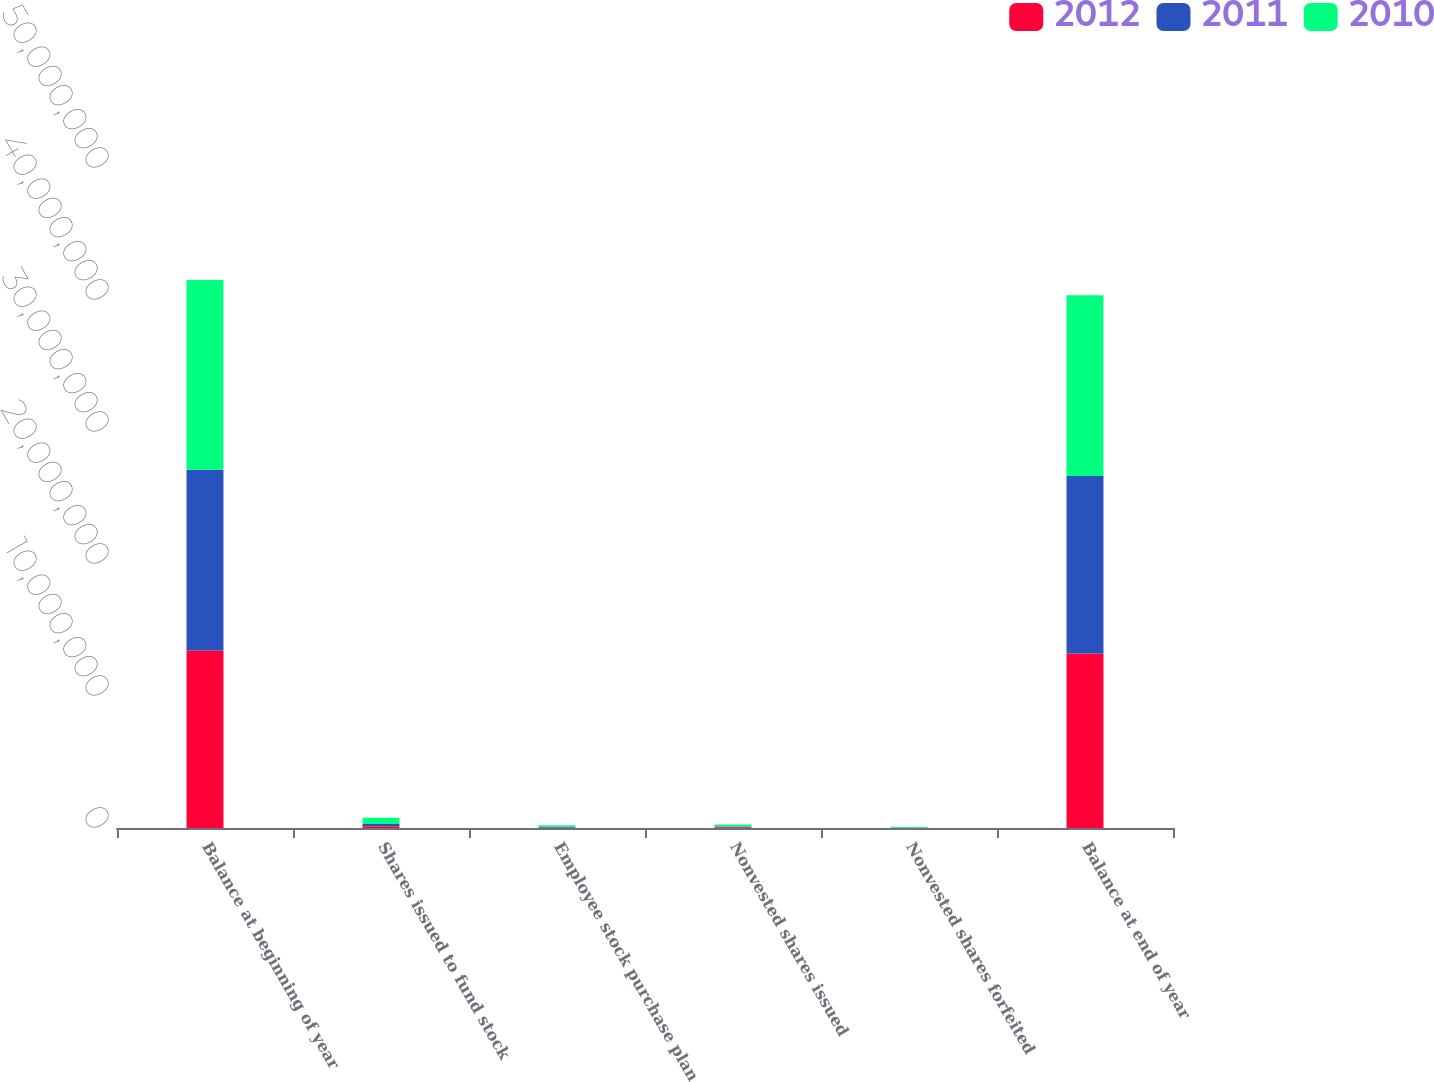Convert chart. <chart><loc_0><loc_0><loc_500><loc_500><stacked_bar_chart><ecel><fcel>Balance at beginning of year<fcel>Shares issued to fund stock<fcel>Employee stock purchase plan<fcel>Nonvested shares issued<fcel>Nonvested shares forfeited<fcel>Balance at end of year<nl><fcel>2012<fcel>1.34413e+07<fcel>141728<fcel>44319<fcel>56136<fcel>21687<fcel>1.32208e+07<nl><fcel>2011<fcel>1.37035e+07<fcel>158440<fcel>59390<fcel>57659<fcel>13364<fcel>1.34413e+07<nl><fcel>2010<fcel>1.43697e+07<fcel>480514<fcel>110850<fcel>143457<fcel>68552<fcel>1.37035e+07<nl></chart> 